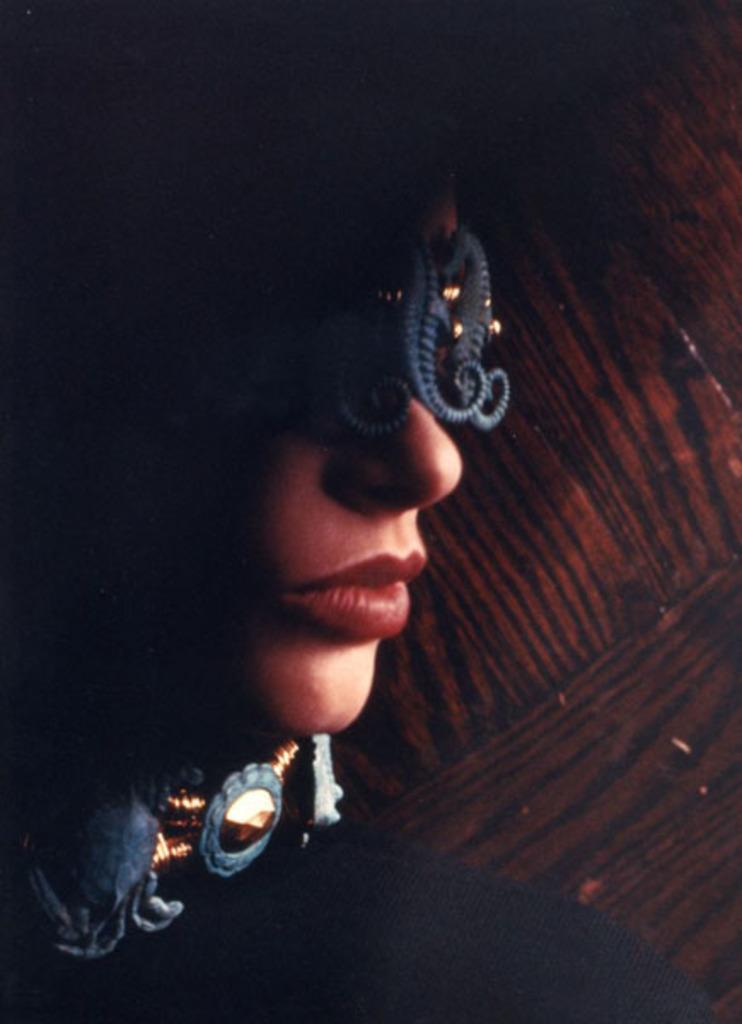What color are the woman's lips in the image? The woman's lips are in red color. What is the color of the background in the image? The background of the image is in brown color. Can you see any fog in the image? There is no fog present in the image. What is the angle of the woman's nose in the image? The angle of the woman's nose cannot be determined from the image, as it is not mentioned in the provided facts. 